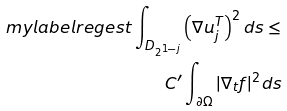<formula> <loc_0><loc_0><loc_500><loc_500>\ m y l a b e l { r e g e s t } \int _ { D _ { 2 ^ { 1 - j } } } \left ( \nabla u ^ { T } _ { j } \right ) ^ { 2 } d s \leq \\ C ^ { \prime } \int _ { \partial \Omega } | \nabla _ { t } f | ^ { 2 } d s</formula> 